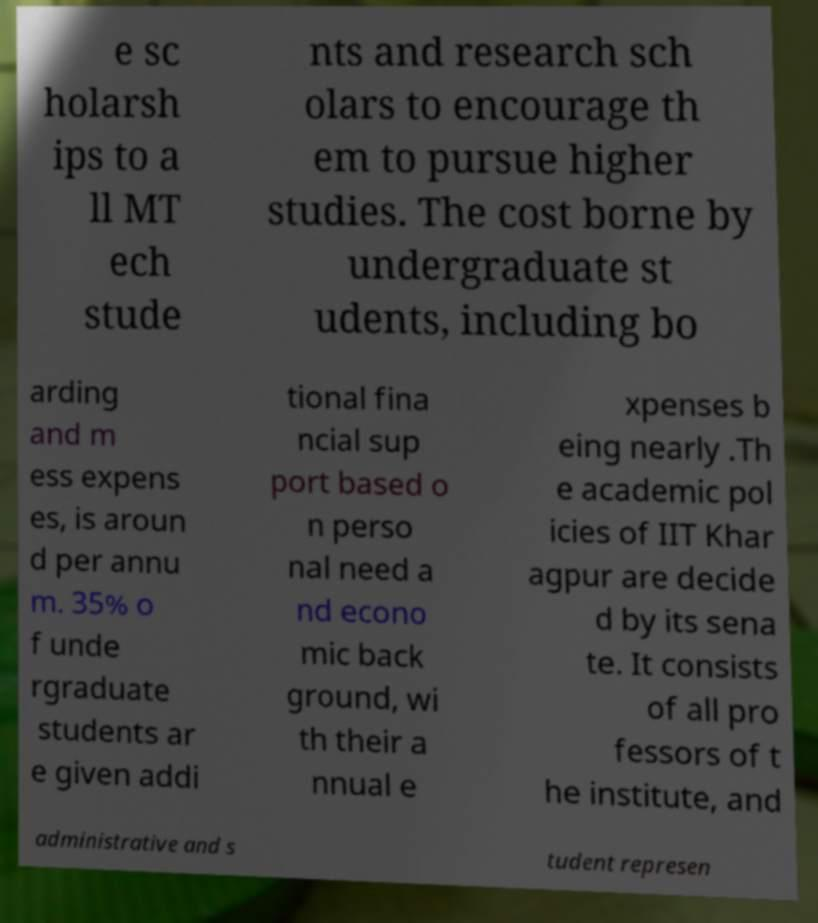What messages or text are displayed in this image? I need them in a readable, typed format. e sc holarsh ips to a ll MT ech stude nts and research sch olars to encourage th em to pursue higher studies. The cost borne by undergraduate st udents, including bo arding and m ess expens es, is aroun d per annu m. 35% o f unde rgraduate students ar e given addi tional fina ncial sup port based o n perso nal need a nd econo mic back ground, wi th their a nnual e xpenses b eing nearly .Th e academic pol icies of IIT Khar agpur are decide d by its sena te. It consists of all pro fessors of t he institute, and administrative and s tudent represen 